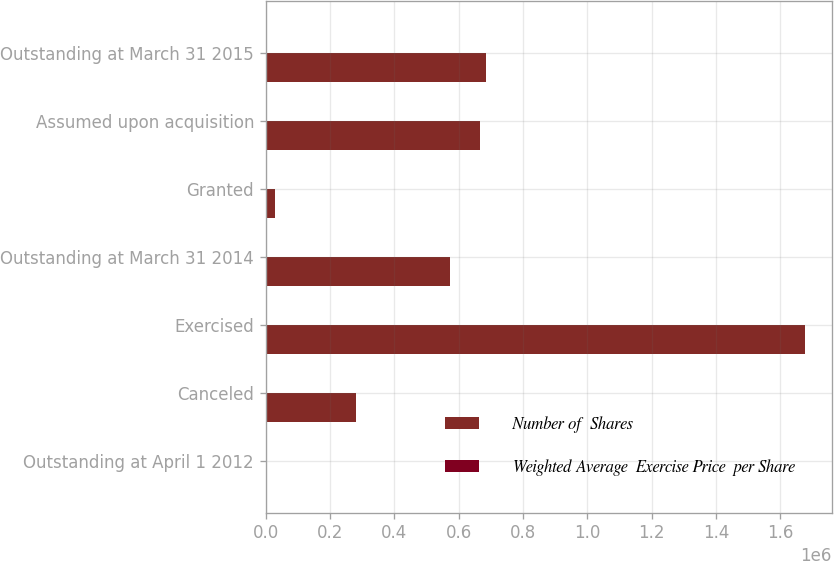Convert chart. <chart><loc_0><loc_0><loc_500><loc_500><stacked_bar_chart><ecel><fcel>Outstanding at April 1 2012<fcel>Canceled<fcel>Exercised<fcel>Outstanding at March 31 2014<fcel>Granted<fcel>Assumed upon acquisition<fcel>Outstanding at March 31 2015<nl><fcel>Number of  Shares<fcel>46.66<fcel>280353<fcel>1.67566e+06<fcel>573611<fcel>27654<fcel>666586<fcel>684299<nl><fcel>Weighted Average  Exercise Price  per Share<fcel>25<fcel>19.9<fcel>25.91<fcel>24.75<fcel>46.66<fcel>29.33<fcel>28.41<nl></chart> 